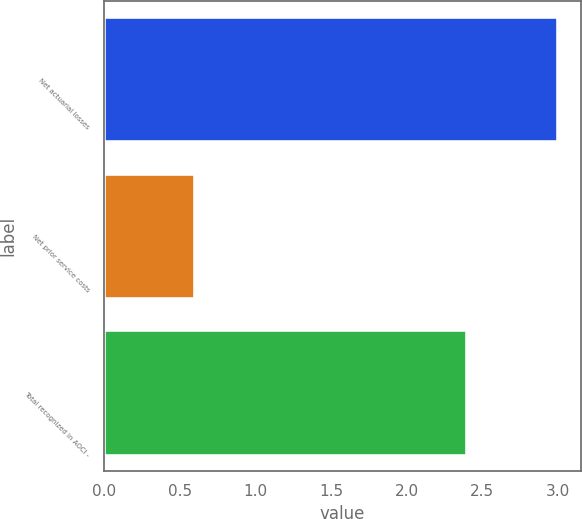Convert chart to OTSL. <chart><loc_0><loc_0><loc_500><loc_500><bar_chart><fcel>Net actuarial losses<fcel>Net prior service costs<fcel>Total recognized in AOCI -<nl><fcel>3<fcel>0.6<fcel>2.4<nl></chart> 